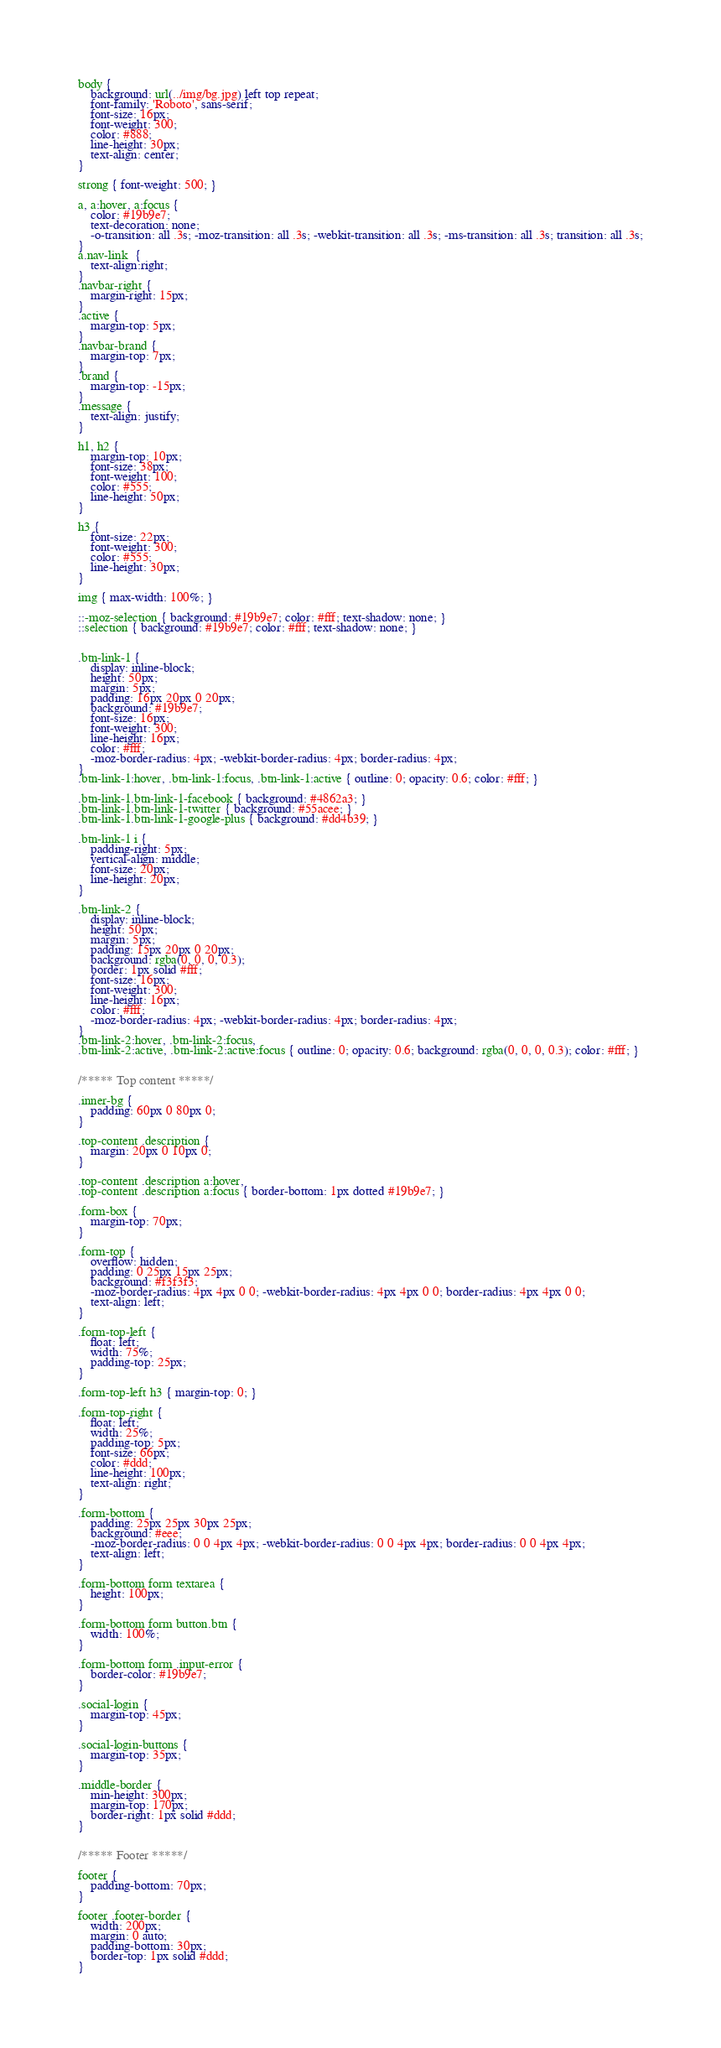Convert code to text. <code><loc_0><loc_0><loc_500><loc_500><_CSS_>
body {
	background: url(../img/bg.jpg) left top repeat;
    font-family: 'Roboto', sans-serif;
    font-size: 16px;
    font-weight: 300;
    color: #888;
    line-height: 30px;
    text-align: center;
}

strong { font-weight: 500; }

a, a:hover, a:focus {
	color: #19b9e7;
	text-decoration: none;
    -o-transition: all .3s; -moz-transition: all .3s; -webkit-transition: all .3s; -ms-transition: all .3s; transition: all .3s;
}
a.nav-link  {
	text-align:right;
}
.navbar-right {
	margin-right: 15px;
}
.active {
	margin-top: 5px;
}
.navbar-brand {
	margin-top: 7px;
}
.brand {
	margin-top: -15px;
}
.message {
	text-align: justify;
}

h1, h2 {
	margin-top: 10px;
	font-size: 38px;
    font-weight: 100;
    color: #555;
    line-height: 50px;
}

h3 {
	font-size: 22px;
    font-weight: 300;
    color: #555;
    line-height: 30px;
}

img { max-width: 100%; }

::-moz-selection { background: #19b9e7; color: #fff; text-shadow: none; }
::selection { background: #19b9e7; color: #fff; text-shadow: none; }


.btn-link-1 {
	display: inline-block;
	height: 50px;
	margin: 5px;
	padding: 16px 20px 0 20px;
	background: #19b9e7;
	font-size: 16px;
    font-weight: 300;
    line-height: 16px;
    color: #fff;
    -moz-border-radius: 4px; -webkit-border-radius: 4px; border-radius: 4px;
}
.btn-link-1:hover, .btn-link-1:focus, .btn-link-1:active { outline: 0; opacity: 0.6; color: #fff; }

.btn-link-1.btn-link-1-facebook { background: #4862a3; }
.btn-link-1.btn-link-1-twitter { background: #55acee; }
.btn-link-1.btn-link-1-google-plus { background: #dd4b39; }

.btn-link-1 i {
	padding-right: 5px;
	vertical-align: middle;
	font-size: 20px;
	line-height: 20px;
}

.btn-link-2 {
	display: inline-block;
	height: 50px;
	margin: 5px;
	padding: 15px 20px 0 20px;
	background: rgba(0, 0, 0, 0.3);
	border: 1px solid #fff;
	font-size: 16px;
    font-weight: 300;
    line-height: 16px;
    color: #fff;
    -moz-border-radius: 4px; -webkit-border-radius: 4px; border-radius: 4px;
}
.btn-link-2:hover, .btn-link-2:focus,
.btn-link-2:active, .btn-link-2:active:focus { outline: 0; opacity: 0.6; background: rgba(0, 0, 0, 0.3); color: #fff; }


/***** Top content *****/

.inner-bg {
    padding: 60px 0 80px 0;
}

.top-content .description {
	margin: 20px 0 10px 0;
}

.top-content .description a:hover,
.top-content .description a:focus { border-bottom: 1px dotted #19b9e7; }

.form-box {
	margin-top: 70px;
}

.form-top {
	overflow: hidden;
	padding: 0 25px 15px 25px;
	background: #f3f3f3;
	-moz-border-radius: 4px 4px 0 0; -webkit-border-radius: 4px 4px 0 0; border-radius: 4px 4px 0 0;
	text-align: left;
}

.form-top-left {
	float: left;
	width: 75%;
	padding-top: 25px;
}

.form-top-left h3 { margin-top: 0; }

.form-top-right {
	float: left;
	width: 25%;
	padding-top: 5px;
	font-size: 66px;
	color: #ddd;
	line-height: 100px;
	text-align: right;
}

.form-bottom {
	padding: 25px 25px 30px 25px;
	background: #eee;
	-moz-border-radius: 0 0 4px 4px; -webkit-border-radius: 0 0 4px 4px; border-radius: 0 0 4px 4px;
	text-align: left;
}

.form-bottom form textarea {
	height: 100px;
}

.form-bottom form button.btn {
	width: 100%;
}

.form-bottom form .input-error {
	border-color: #19b9e7;
}

.social-login {
	margin-top: 45px;
}

.social-login-buttons {
	margin-top: 35px;
}

.middle-border {
	min-height: 300px;
	margin-top: 170px;
	border-right: 1px solid #ddd;
}


/***** Footer *****/

footer {
	padding-bottom: 70px;
}

footer .footer-border {
	width: 200px;
	margin: 0 auto;
	padding-bottom: 30px;
	border-top: 1px solid #ddd;
}
</code> 